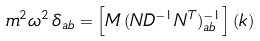<formula> <loc_0><loc_0><loc_500><loc_500>m ^ { 2 } \omega ^ { 2 } \, \delta _ { a b } = \left [ M \, ( N D ^ { - 1 } N ^ { T } ) ^ { - 1 } _ { a b } \right ] ( { k } )</formula> 